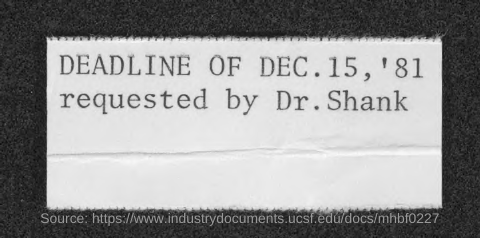Draw attention to some important aspects in this diagram. On December 15, 1981, Dr. Shank requested the deadline. 